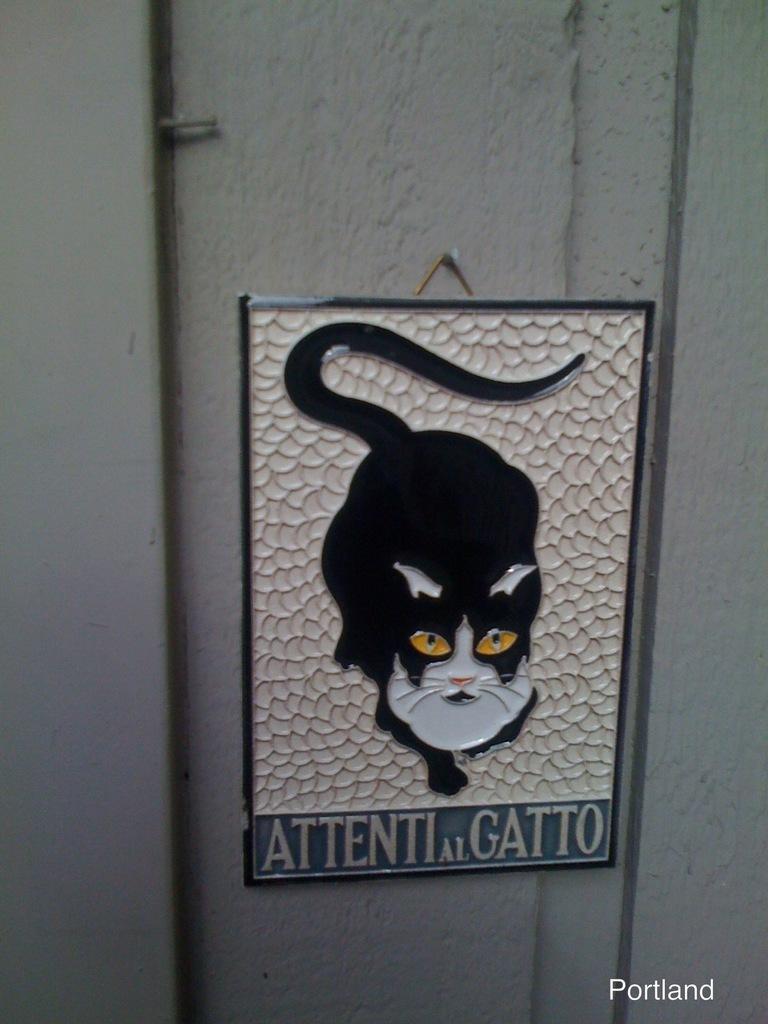Could you give a brief overview of what you see in this image? In this picture we can see board on the wall, on the board we can see a cat and text. In the bottom right side of the image we can see text. 